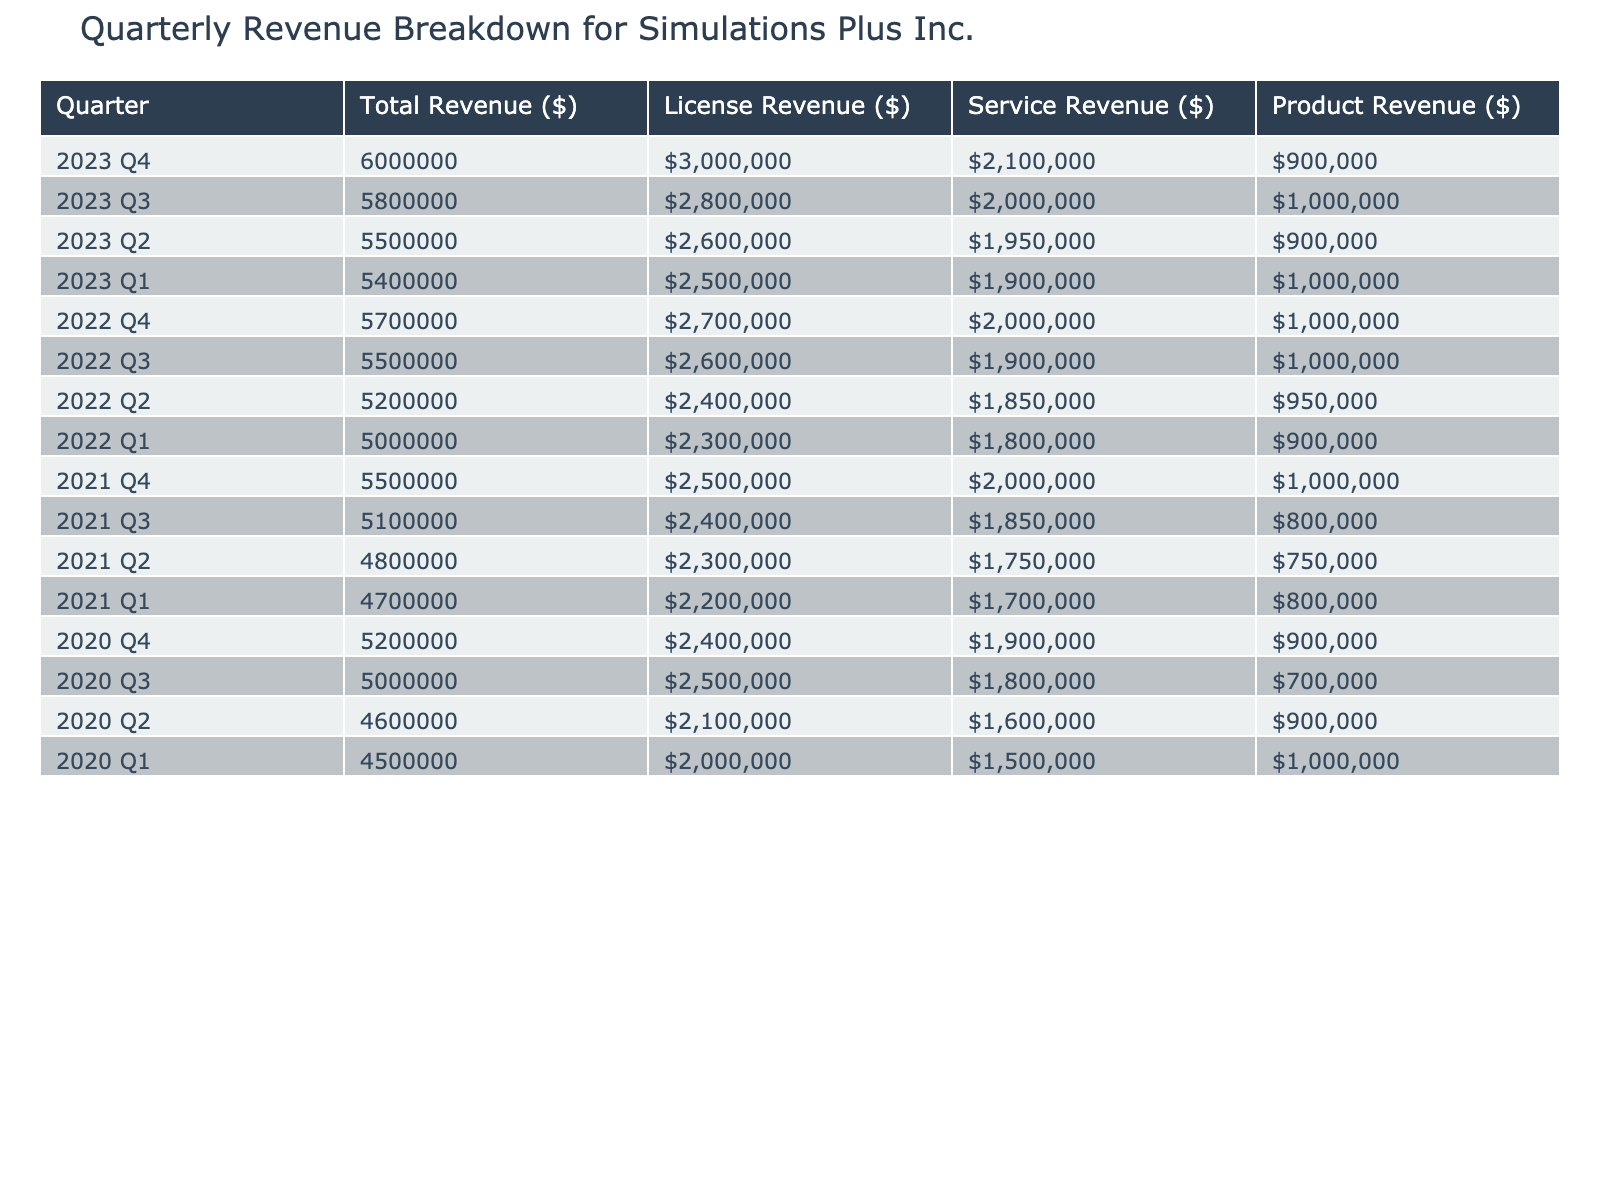What was the total revenue in Q4 2022? In the table, I can find the row for Q4 2022, which shows the total revenue as $5,700,000.
Answer: $5,700,000 Which quarter had the highest service revenue? I can compare the service revenue for each quarter. The highest service revenue is $2,100,000 in Q4 2023.
Answer: $2,100,000 What was the average total revenue over the last four quarters of 2023? To find the average, I sum the total revenues for Q1, Q2, Q3, and Q4 of 2023: ($5,400,000 + $5,500,000 + $5,800,000 + $6,000,000) = $22,700,000. Then, I divide by 4: $22,700,000 / 4 = $5,675,000.
Answer: $5,675,000 In which year did the company first exceed $5,500,000 in total revenue? Looking through the yearly breakdown, I see that in Q4 2021, the total revenue was $5,500,000, which means that year is when the company first exceeded that amount.
Answer: 2021 Was the license revenue greater than service revenue in Q3 2021? I can check the license and service revenue for Q3 2021. The license revenue is $2,400,000, and the service revenue is $1,850,000. Since $2,400,000 is greater than $1,850,000, the statement is true.
Answer: Yes How much did product revenue change from Q1 2023 to Q4 2023? The product revenue in Q1 2023 is $1,000,000 and in Q4 2023 it is $900,000. To find the change, I subtract: $900,000 - $1,000,000 = -$100,000. The product revenue decreased by $100,000.
Answer: Decreased by $100,000 What is the total revenue for the entire year of 2022? I sum the total revenues for each quarter in 2022: ($5,000,000 + $5,200,000 + $5,500,000 + $5,700,000) = $21,400,000.
Answer: $21,400,000 Which quarter had the lowest total revenue over the last four years? I review the total revenue for each quarter and find Q1 2020 with a total revenue of $4,500,000 is the lowest.
Answer: Q1 2020 What is the difference between the highest and lowest product revenue in the table? The highest product revenue in the table is $1,000,000 in Q1 2020 and the lowest is $700,000 in Q3 2020. I subtract: $1,000,000 - $700,000 = $300,000.
Answer: $300,000 Did the total revenue consistently increase from Q1 2022 to Q4 2022? I can examine the total revenues for those quarters: Q1 2022 ($5,000,000), Q2 2022 ($5,200,000), Q3 2022 ($5,500,000), Q4 2022 ($5,700,000). Since they all increase, the answer is yes.
Answer: Yes 